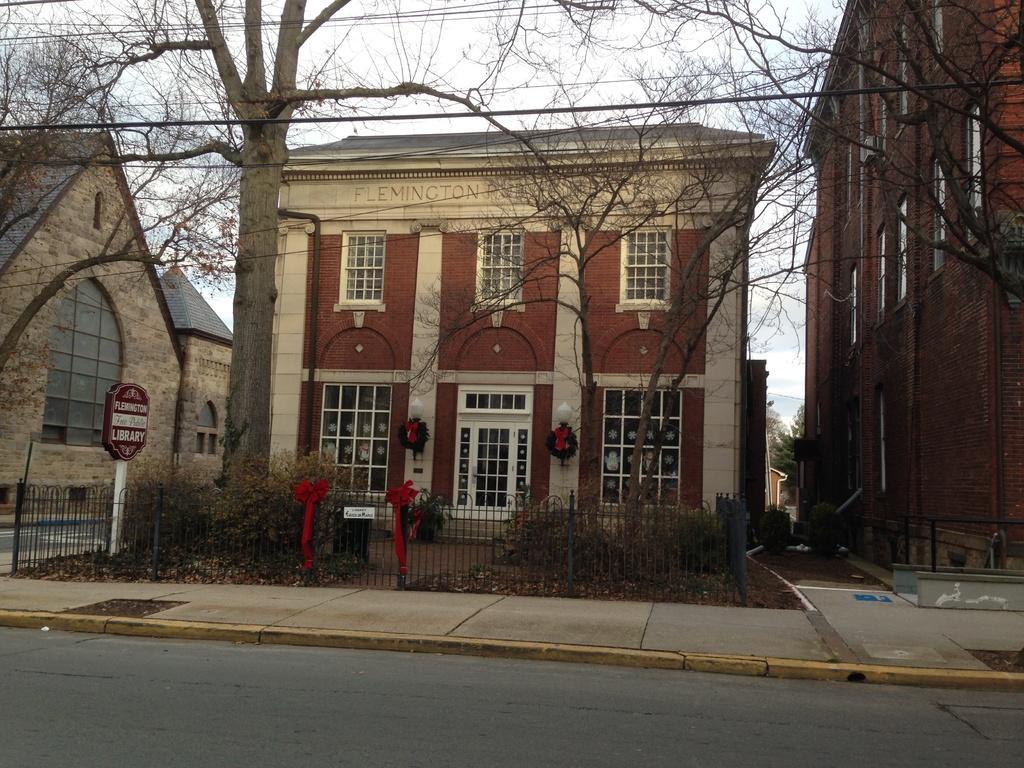How would you summarize this image in a sentence or two? In this picture we can see buildings in the background, there are trees, some plants, fencing and a board present in the middle, at the bottom there are some leaves, we can see the sky and wires at the top of the picture. 